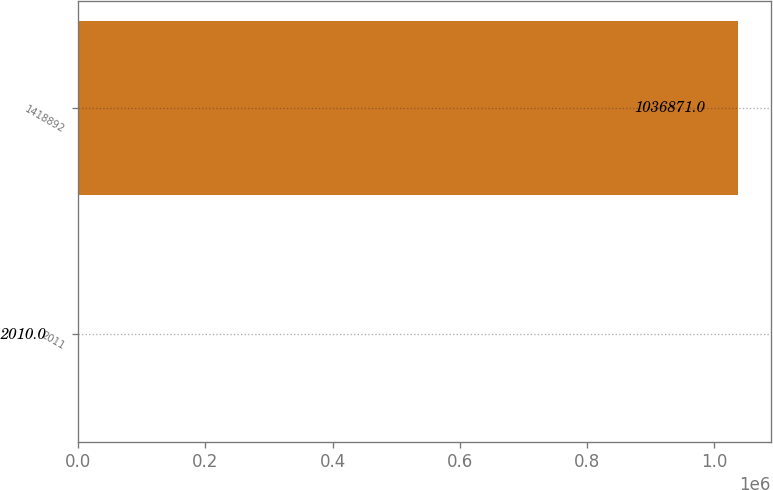Convert chart to OTSL. <chart><loc_0><loc_0><loc_500><loc_500><bar_chart><fcel>2011<fcel>1418892<nl><fcel>2010<fcel>1.03687e+06<nl></chart> 